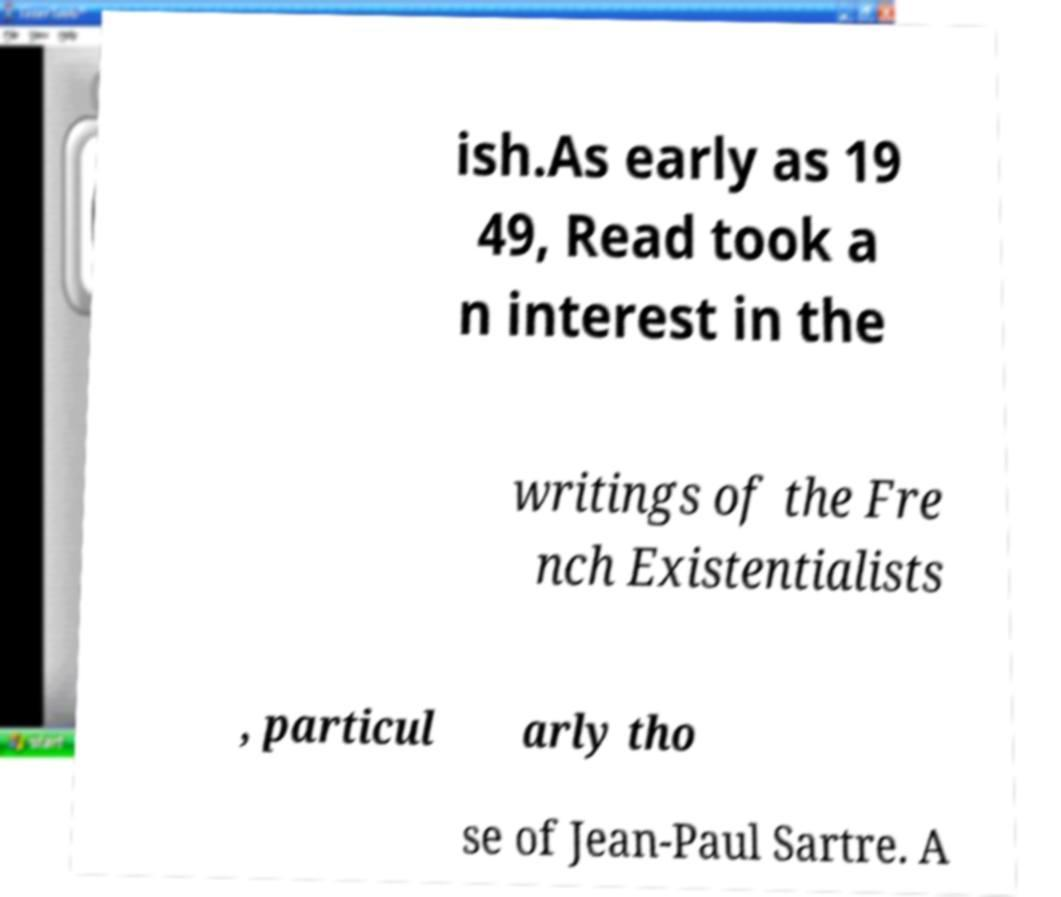Can you accurately transcribe the text from the provided image for me? ish.As early as 19 49, Read took a n interest in the writings of the Fre nch Existentialists , particul arly tho se of Jean-Paul Sartre. A 